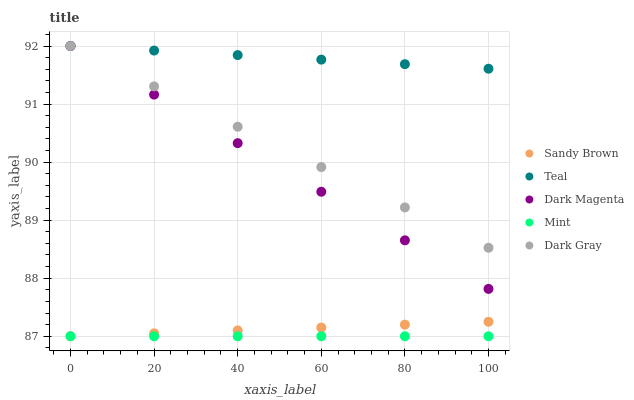Does Mint have the minimum area under the curve?
Answer yes or no. Yes. Does Teal have the maximum area under the curve?
Answer yes or no. Yes. Does Sandy Brown have the minimum area under the curve?
Answer yes or no. No. Does Sandy Brown have the maximum area under the curve?
Answer yes or no. No. Is Mint the smoothest?
Answer yes or no. Yes. Is Teal the roughest?
Answer yes or no. Yes. Is Dark Magenta the smoothest?
Answer yes or no. No. Is Dark Magenta the roughest?
Answer yes or no. No. Does Mint have the lowest value?
Answer yes or no. Yes. Does Dark Magenta have the lowest value?
Answer yes or no. No. Does Teal have the highest value?
Answer yes or no. Yes. Does Sandy Brown have the highest value?
Answer yes or no. No. Is Mint less than Dark Magenta?
Answer yes or no. Yes. Is Teal greater than Mint?
Answer yes or no. Yes. Does Dark Magenta intersect Dark Gray?
Answer yes or no. Yes. Is Dark Magenta less than Dark Gray?
Answer yes or no. No. Is Dark Magenta greater than Dark Gray?
Answer yes or no. No. Does Mint intersect Dark Magenta?
Answer yes or no. No. 